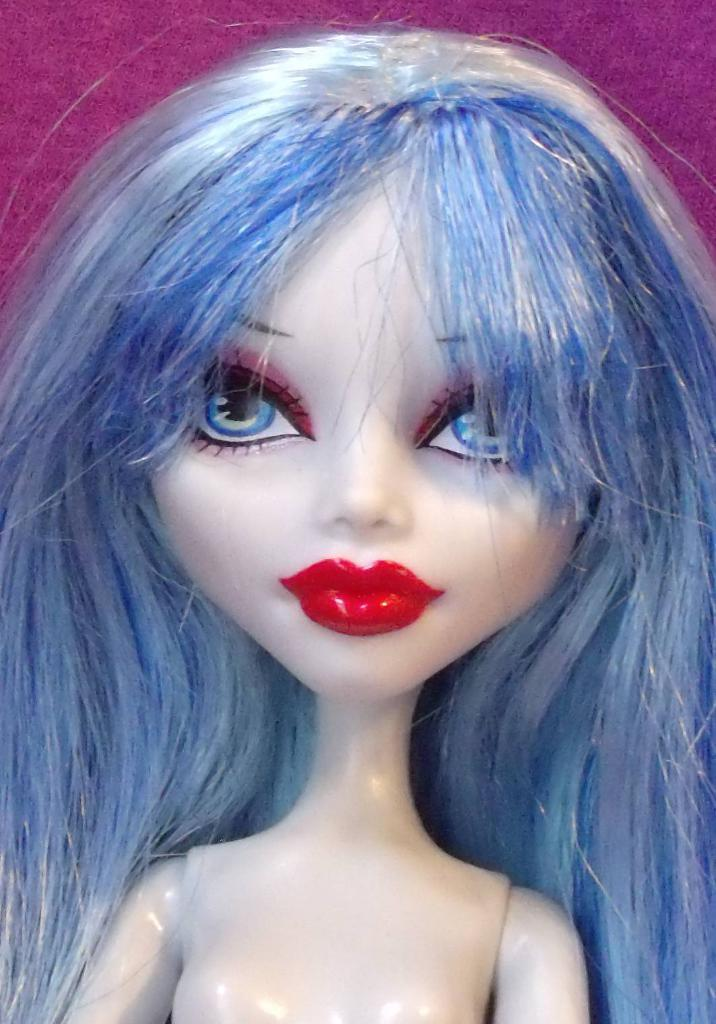What is the main subject of the image? There is a Barbie doll in the image. Where is the Barbie doll located in the image? The Barbie doll is in the center of the image. What type of industry is depicted in the image? There is no industry depicted in the image; it features a Barbie doll. What kind of cloth is the Barbie doll wearing in the image? The provided facts do not mention any clothing on the Barbie doll, so we cannot determine the type of cloth. Are there any crows visible in the image? There are no crows present in the image; it features a Barbie doll. 